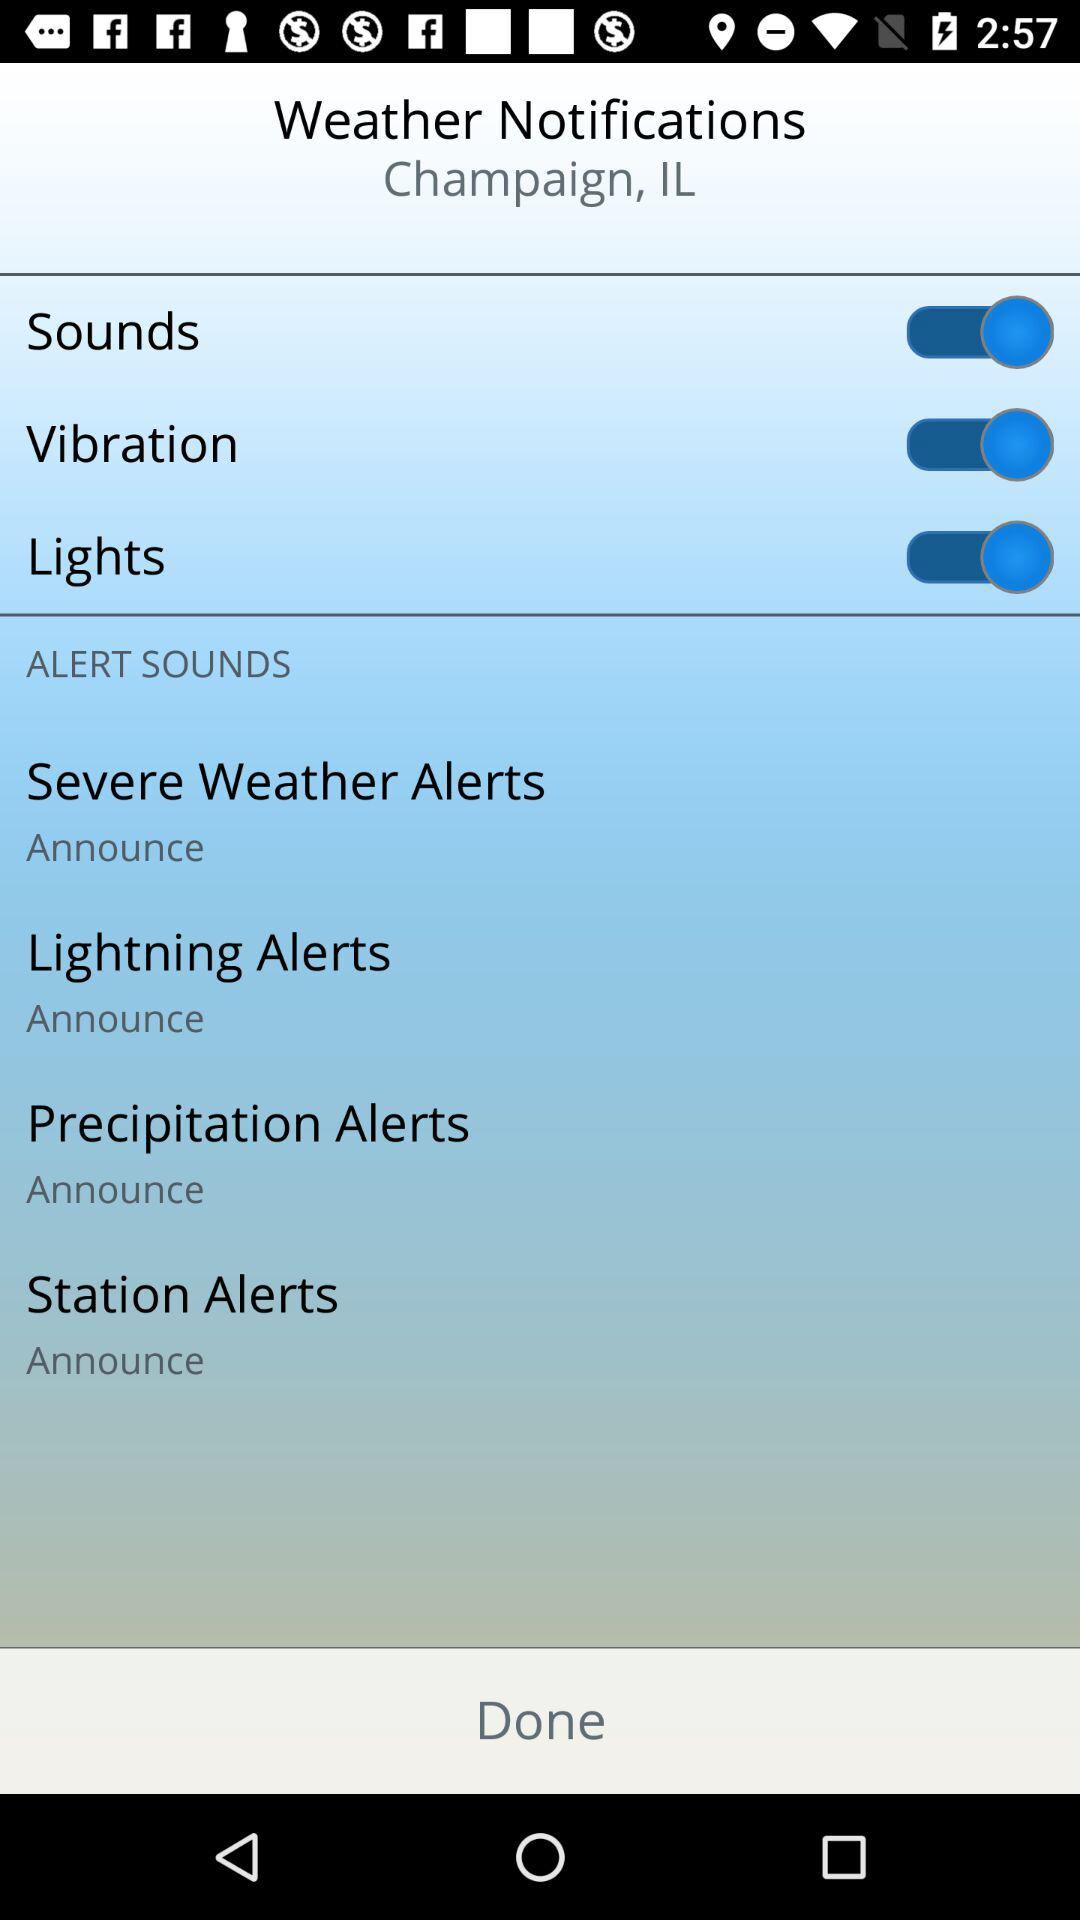What is the status of the sounds? The status is "on". 